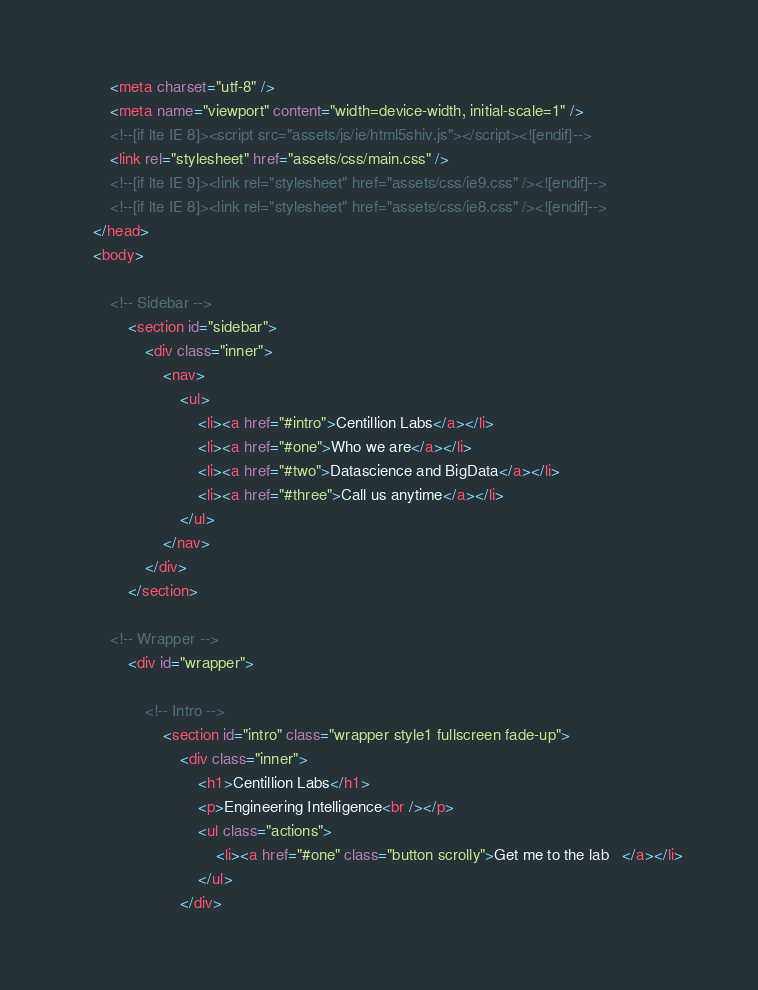Convert code to text. <code><loc_0><loc_0><loc_500><loc_500><_HTML_>		<meta charset="utf-8" />
		<meta name="viewport" content="width=device-width, initial-scale=1" />
		<!--[if lte IE 8]><script src="assets/js/ie/html5shiv.js"></script><![endif]-->
		<link rel="stylesheet" href="assets/css/main.css" />
		<!--[if lte IE 9]><link rel="stylesheet" href="assets/css/ie9.css" /><![endif]-->
		<!--[if lte IE 8]><link rel="stylesheet" href="assets/css/ie8.css" /><![endif]-->
	</head>
	<body>

		<!-- Sidebar -->
			<section id="sidebar">
				<div class="inner">
					<nav>
						<ul>
							<li><a href="#intro">Centillion Labs</a></li>
							<li><a href="#one">Who we are</a></li>
							<li><a href="#two">Datascience and BigData</a></li>
							<li><a href="#three">Call us anytime</a></li>
						</ul>
					</nav>
				</div>
			</section>

		<!-- Wrapper -->
			<div id="wrapper">

				<!-- Intro -->
					<section id="intro" class="wrapper style1 fullscreen fade-up">
						<div class="inner">
							<h1>Centillion Labs</h1>
							<p>Engineering Intelligence<br /></p>
							<ul class="actions">
								<li><a href="#one" class="button scrolly">Get me to the lab	</a></li>
							</ul>
						</div></code> 